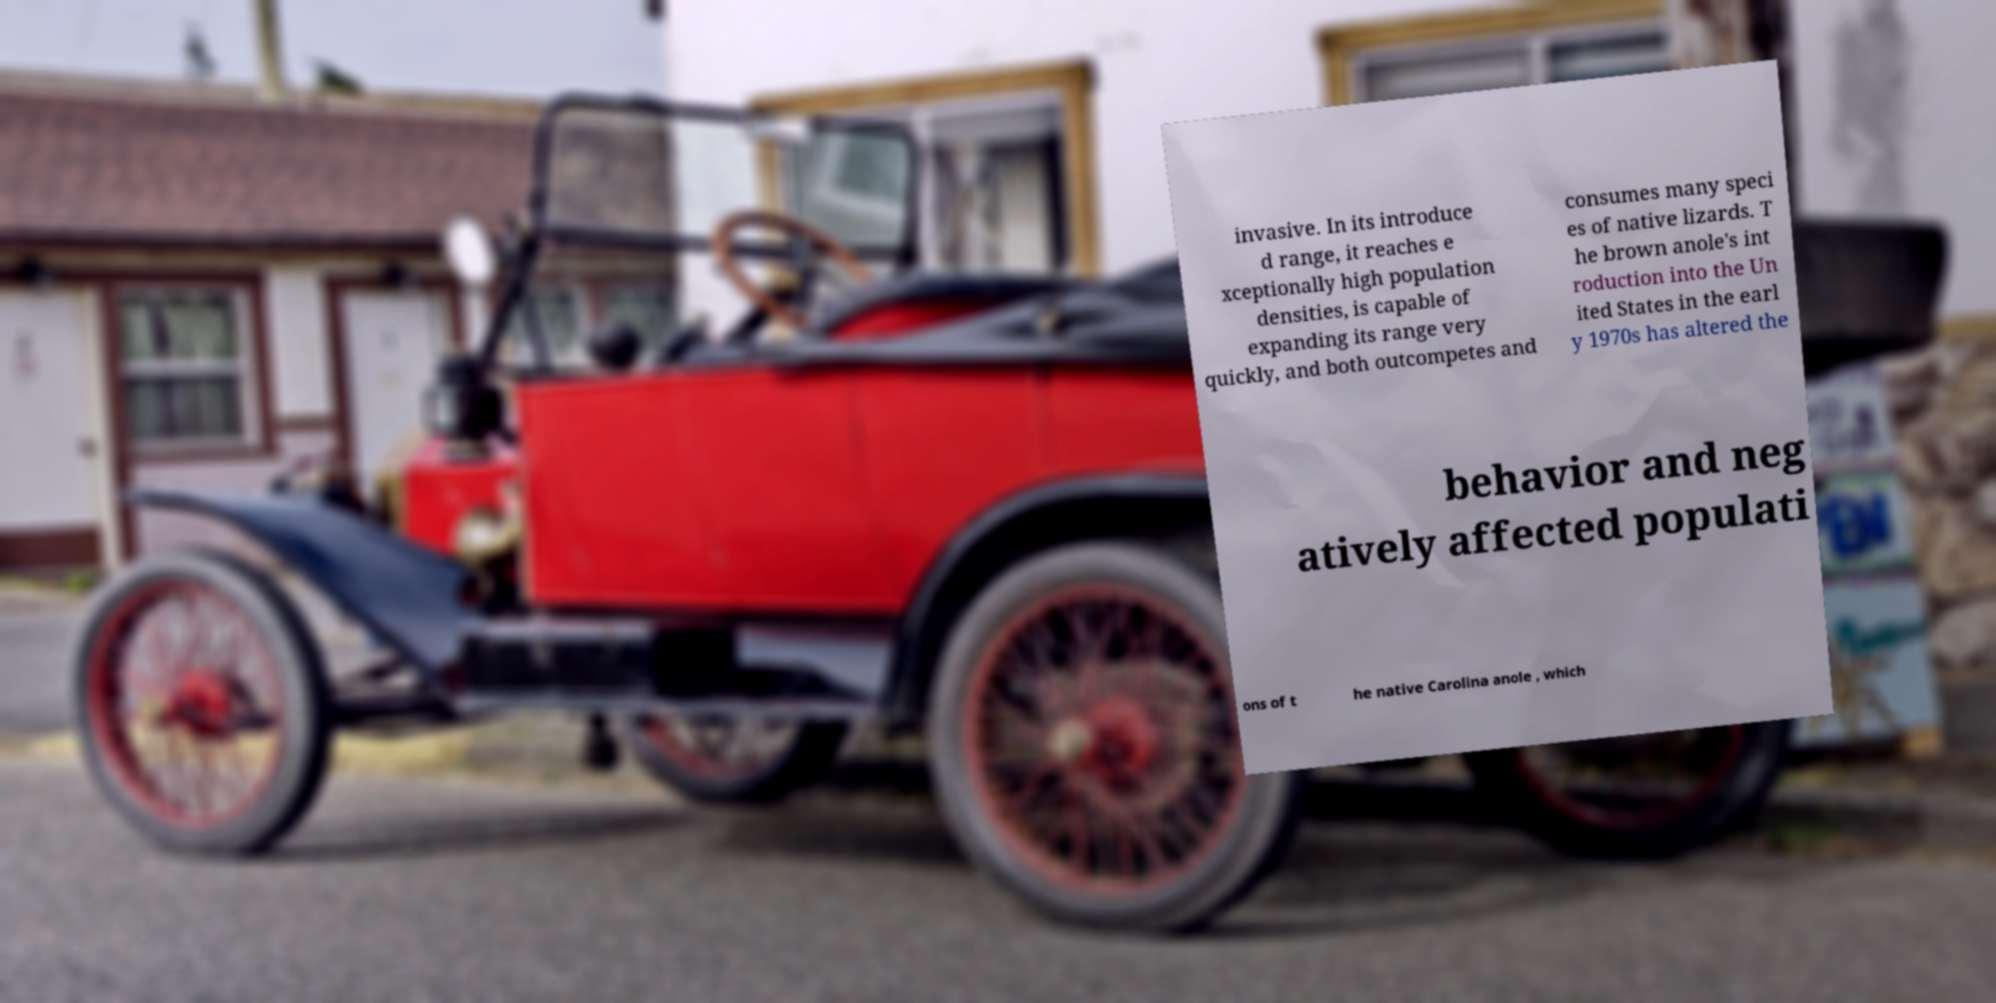Could you assist in decoding the text presented in this image and type it out clearly? invasive. In its introduce d range, it reaches e xceptionally high population densities, is capable of expanding its range very quickly, and both outcompetes and consumes many speci es of native lizards. T he brown anole's int roduction into the Un ited States in the earl y 1970s has altered the behavior and neg atively affected populati ons of t he native Carolina anole , which 